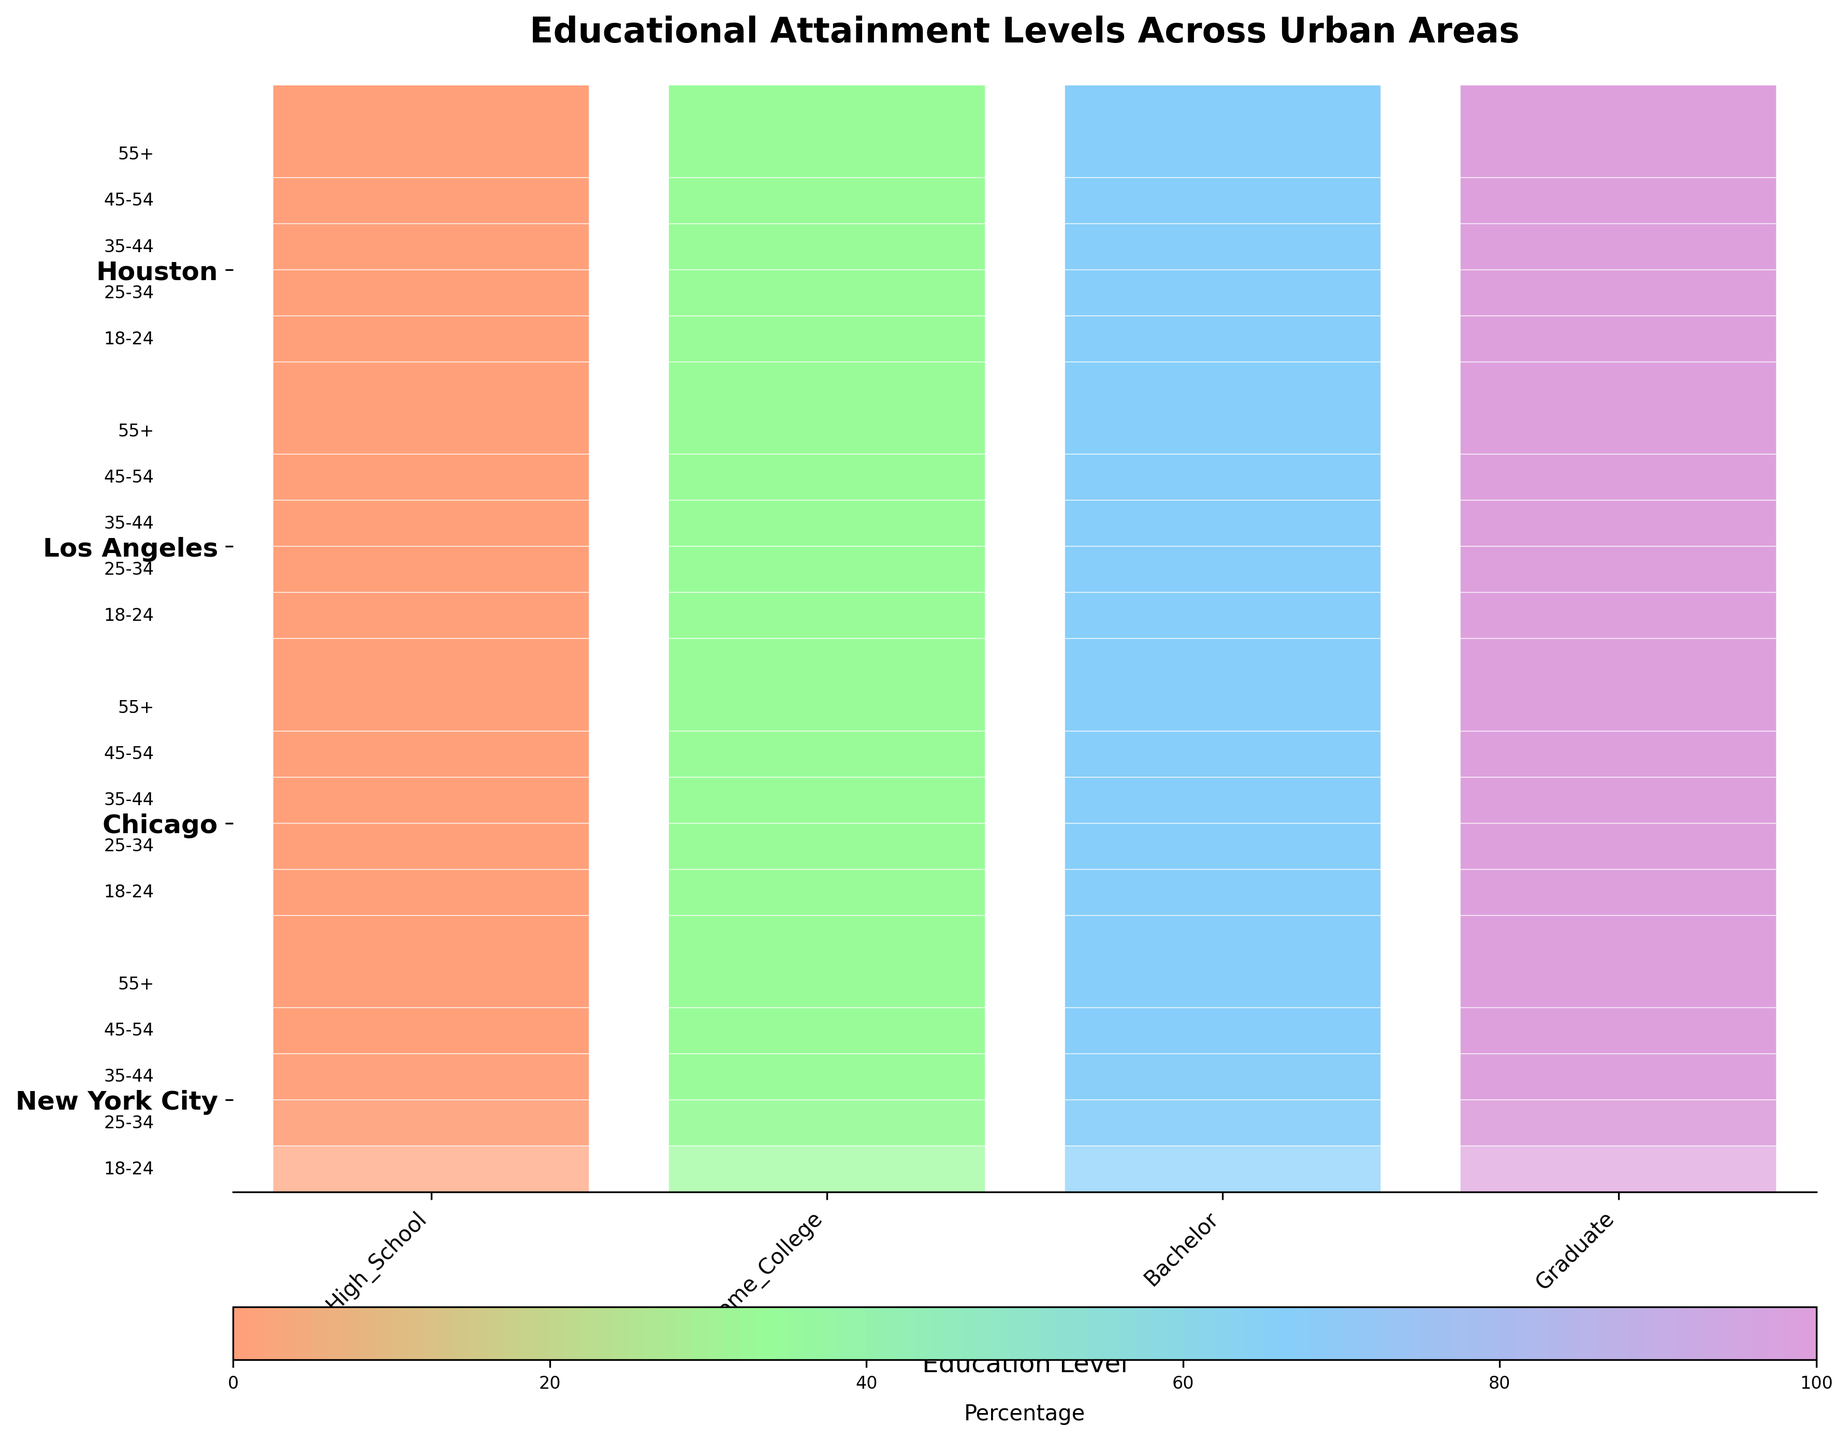What is the title of the plot? The title of the plot is located at the top center of the figure. It should provide a brief description of the data visualized.
Answer: Educational Attainment Levels Across Urban Areas What city shows the highest percentage of people with a Bachelor's degree in the 25-34 age group? To find the highest percentage, look at the bars representing the Bachelor's degree level for the 25-34 age group across different cities. The height of these bars indicates the percentage.
Answer: New York City Which age group in Chicago has the highest proportion of individuals with a Graduate degree? Locate the Graduate degree bars for each age group in the Chicago section. Compare their heights to determine the highest proportion.
Answer: 45-54 What is the average percentage of people with a High School diploma in Houston across all age groups? Identify the High School bars for Houston in all age groups. Sum their heights and divide by the number of age groups (5) to get the average. (35 + 30 + 25 + 22 + 28) / 5 = 140 / 5 = 28
Answer: 28 Compare the proportion of people with some college education in the 18-24 age group between Los Angeles and Houston. Which city has a higher proportion? Look at the Some College bars in the 18-24 age group rows for Los Angeles and Houston. Compare their heights to see which is taller.
Answer: Los Angeles In New York City, which age group has the lowest percentage of high school graduates? Locate the High School bars within the New York City section. Identify the shortest bar to find the lowest percentage.
Answer: 45-54 What is the difference in the percentage of individuals with a Graduate degree between the 35-44 and 55+ age groups in Los Angeles? Identify the Graduate bars for the 35-44 and 55+ age groups in Los Angeles. Subtract the percentage of the 55+ group from the 35-44 group. 22 - 15 = 7
Answer: 7 What city has the least variation in educational attainment across all age groups? To determine the least variation, examine the bars across different education levels for each city. Look for the city where the bars across age groups are most similar in height.
Answer: Chicago In which city do individuals in the 45-54 age group have the highest percentage of a Bachelor's degree? Identify the Bachelor's degree bars for the 45-54 age group across all cities and find the tallest bar.
Answer: Los Angeles Which age group in New York City has the highest overall educational attainment? In the New York City section, sum the heights of all four educational attainment bars for each age group. The age group with the highest total sum has the highest overall educational attainment.
Answer: 45-54 